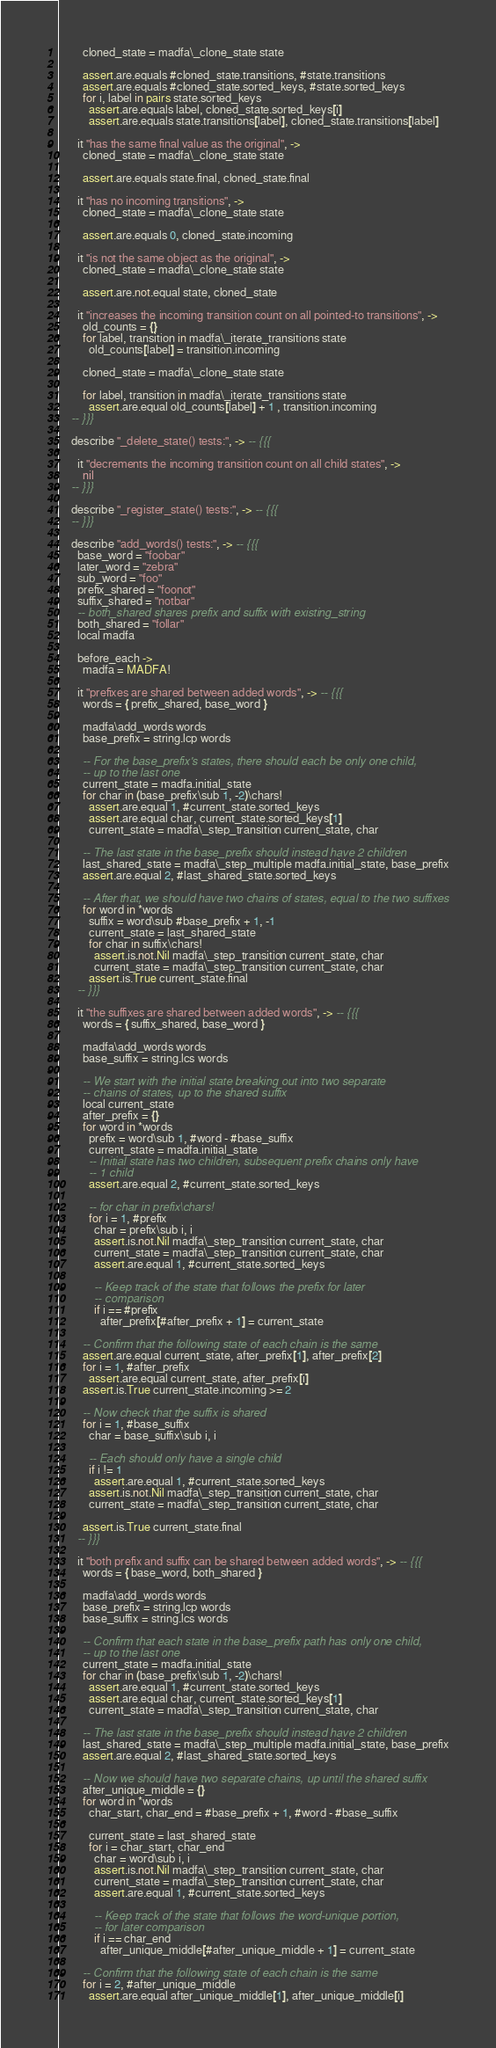<code> <loc_0><loc_0><loc_500><loc_500><_MoonScript_>        cloned_state = madfa\_clone_state state

        assert.are.equals #cloned_state.transitions, #state.transitions
        assert.are.equals #cloned_state.sorted_keys, #state.sorted_keys
        for i, label in pairs state.sorted_keys
          assert.are.equals label, cloned_state.sorted_keys[i]
          assert.are.equals state.transitions[label], cloned_state.transitions[label]

      it "has the same final value as the original", ->
        cloned_state = madfa\_clone_state state

        assert.are.equals state.final, cloned_state.final

      it "has no incoming transitions", ->
        cloned_state = madfa\_clone_state state

        assert.are.equals 0, cloned_state.incoming

      it "is not the same object as the original", ->
        cloned_state = madfa\_clone_state state

        assert.are.not.equal state, cloned_state

      it "increases the incoming transition count on all pointed-to transitions", ->
        old_counts = {}
        for label, transition in madfa\_iterate_transitions state
          old_counts[label] = transition.incoming

        cloned_state = madfa\_clone_state state

        for label, transition in madfa\_iterate_transitions state
          assert.are.equal old_counts[label] + 1 , transition.incoming
    -- }}}

    describe "_delete_state() tests:", -> -- {{{

      it "decrements the incoming transition count on all child states", -> 
        nil
    -- }}}

    describe "_register_state() tests:", -> -- {{{
    -- }}}

    describe "add_words() tests:", -> -- {{{
      base_word = "foobar"
      later_word = "zebra"
      sub_word = "foo"
      prefix_shared = "foonot"
      suffix_shared = "notbar"
      -- both_shared shares prefix and suffix with existing_string
      both_shared = "follar"
      local madfa

      before_each ->
        madfa = MADFA!

      it "prefixes are shared between added words", -> -- {{{
        words = { prefix_shared, base_word }

        madfa\add_words words
        base_prefix = string.lcp words

        -- For the base_prefix's states, there should each be only one child,
        -- up to the last one
        current_state = madfa.initial_state
        for char in (base_prefix\sub 1, -2)\chars!
          assert.are.equal 1, #current_state.sorted_keys
          assert.are.equal char, current_state.sorted_keys[1]
          current_state = madfa\_step_transition current_state, char

        -- The last state in the base_prefix should instead have 2 children
        last_shared_state = madfa\_step_multiple madfa.initial_state, base_prefix
        assert.are.equal 2, #last_shared_state.sorted_keys

        -- After that, we should have two chains of states, equal to the two suffixes
        for word in *words
          suffix = word\sub #base_prefix + 1, -1
          current_state = last_shared_state
          for char in suffix\chars!
            assert.is.not.Nil madfa\_step_transition current_state, char
            current_state = madfa\_step_transition current_state, char
          assert.is.True current_state.final
      -- }}}

      it "the suffixes are shared between added words", -> -- {{{
        words = { suffix_shared, base_word }

        madfa\add_words words
        base_suffix = string.lcs words

        -- We start with the initial state breaking out into two separate
        -- chains of states, up to the shared suffix
        local current_state
        after_prefix = {}
        for word in *words
          prefix = word\sub 1, #word - #base_suffix
          current_state = madfa.initial_state
          -- Initial state has two children, subsequent prefix chains only have
          -- 1 child
          assert.are.equal 2, #current_state.sorted_keys

          -- for char in prefix\chars!
          for i = 1, #prefix
            char = prefix\sub i, i
            assert.is.not.Nil madfa\_step_transition current_state, char
            current_state = madfa\_step_transition current_state, char
            assert.are.equal 1, #current_state.sorted_keys

            -- Keep track of the state that follows the prefix for later
            -- comparison
            if i == #prefix
              after_prefix[#after_prefix + 1] = current_state

        -- Confirm that the following state of each chain is the same
        assert.are.equal current_state, after_prefix[1], after_prefix[2]
        for i = 1, #after_prefix
          assert.are.equal current_state, after_prefix[i]
        assert.is.True current_state.incoming >= 2

        -- Now check that the suffix is shared
        for i = 1, #base_suffix
          char = base_suffix\sub i, i

          -- Each should only have a single child
          if i != 1
            assert.are.equal 1, #current_state.sorted_keys
          assert.is.not.Nil madfa\_step_transition current_state, char
          current_state = madfa\_step_transition current_state, char

        assert.is.True current_state.final
      -- }}}

      it "both prefix and suffix can be shared between added words", -> -- {{{
        words = { base_word, both_shared }

        madfa\add_words words
        base_prefix = string.lcp words
        base_suffix = string.lcs words

        -- Confirm that each state in the base_prefix path has only one child,
        -- up to the last one
        current_state = madfa.initial_state
        for char in (base_prefix\sub 1, -2)\chars!
          assert.are.equal 1, #current_state.sorted_keys
          assert.are.equal char, current_state.sorted_keys[1]
          current_state = madfa\_step_transition current_state, char

        -- The last state in the base_prefix should instead have 2 children
        last_shared_state = madfa\_step_multiple madfa.initial_state, base_prefix
        assert.are.equal 2, #last_shared_state.sorted_keys

        -- Now we should have two separate chains, up until the shared suffix
        after_unique_middle = {}
        for word in *words
          char_start, char_end = #base_prefix + 1, #word - #base_suffix

          current_state = last_shared_state
          for i = char_start, char_end
            char = word\sub i, i
            assert.is.not.Nil madfa\_step_transition current_state, char
            current_state = madfa\_step_transition current_state, char
            assert.are.equal 1, #current_state.sorted_keys

            -- Keep track of the state that follows the word-unique portion,
            -- for later comparison
            if i == char_end
              after_unique_middle[#after_unique_middle + 1] = current_state

        -- Confirm that the following state of each chain is the same
        for i = 2, #after_unique_middle
          assert.are.equal after_unique_middle[1], after_unique_middle[i]</code> 